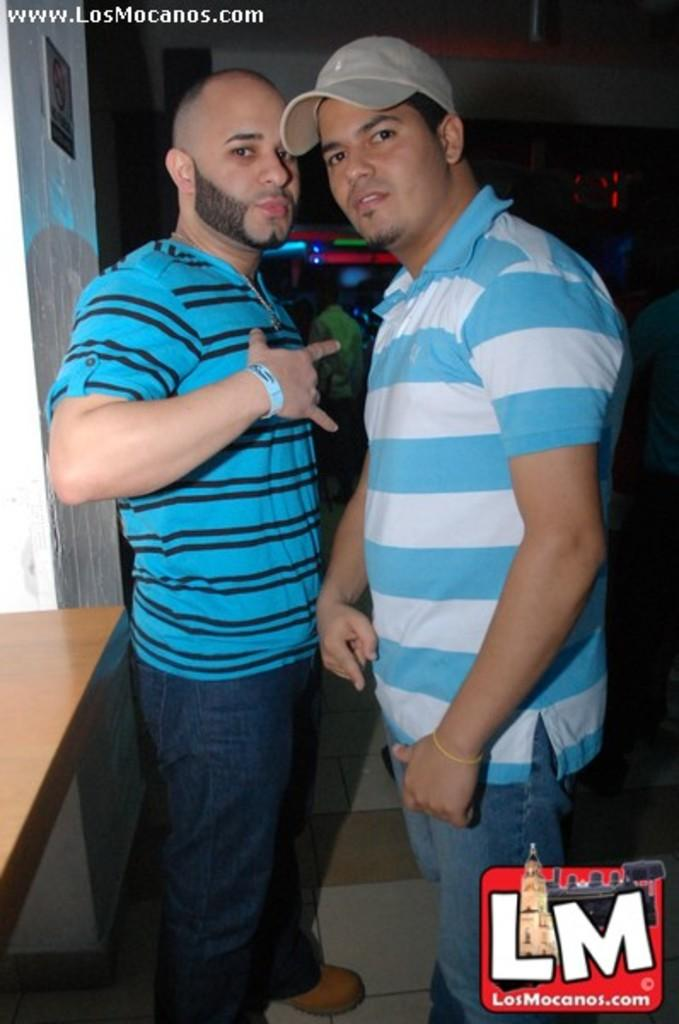How many people are present in the image? There are two persons in the image. What is the main object in the image? There is a table in the image. Where are the people located in the image? There are people standing on the floor in the image. What can be seen illuminating the scene in the image? There are lights visible in the image. What type of hen is sitting on the table in the image? There is no hen present in the image; it only features two persons and a table. 